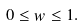<formula> <loc_0><loc_0><loc_500><loc_500>0 \leq w \leq 1 .</formula> 